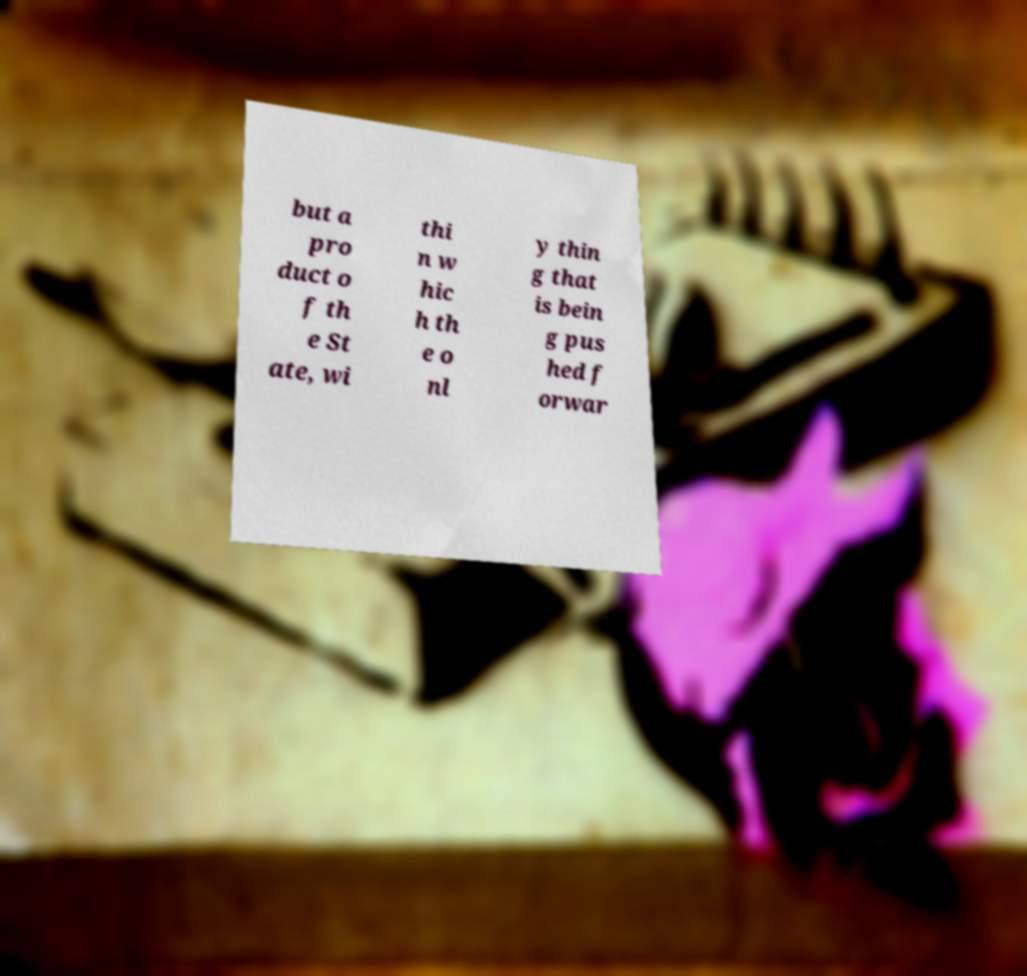I need the written content from this picture converted into text. Can you do that? but a pro duct o f th e St ate, wi thi n w hic h th e o nl y thin g that is bein g pus hed f orwar 